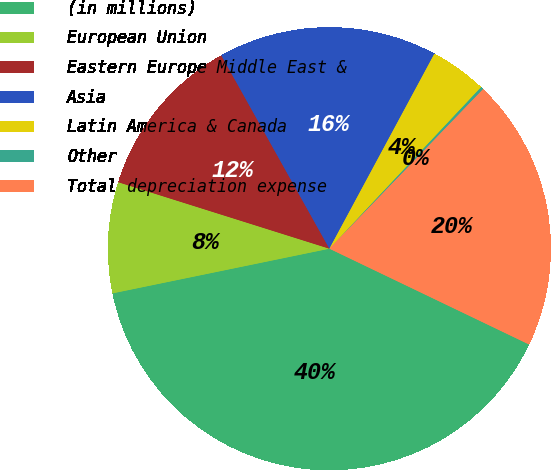Convert chart to OTSL. <chart><loc_0><loc_0><loc_500><loc_500><pie_chart><fcel>(in millions)<fcel>European Union<fcel>Eastern Europe Middle East &<fcel>Asia<fcel>Latin America & Canada<fcel>Other<fcel>Total depreciation expense<nl><fcel>39.65%<fcel>8.09%<fcel>12.03%<fcel>15.98%<fcel>4.14%<fcel>0.2%<fcel>19.92%<nl></chart> 